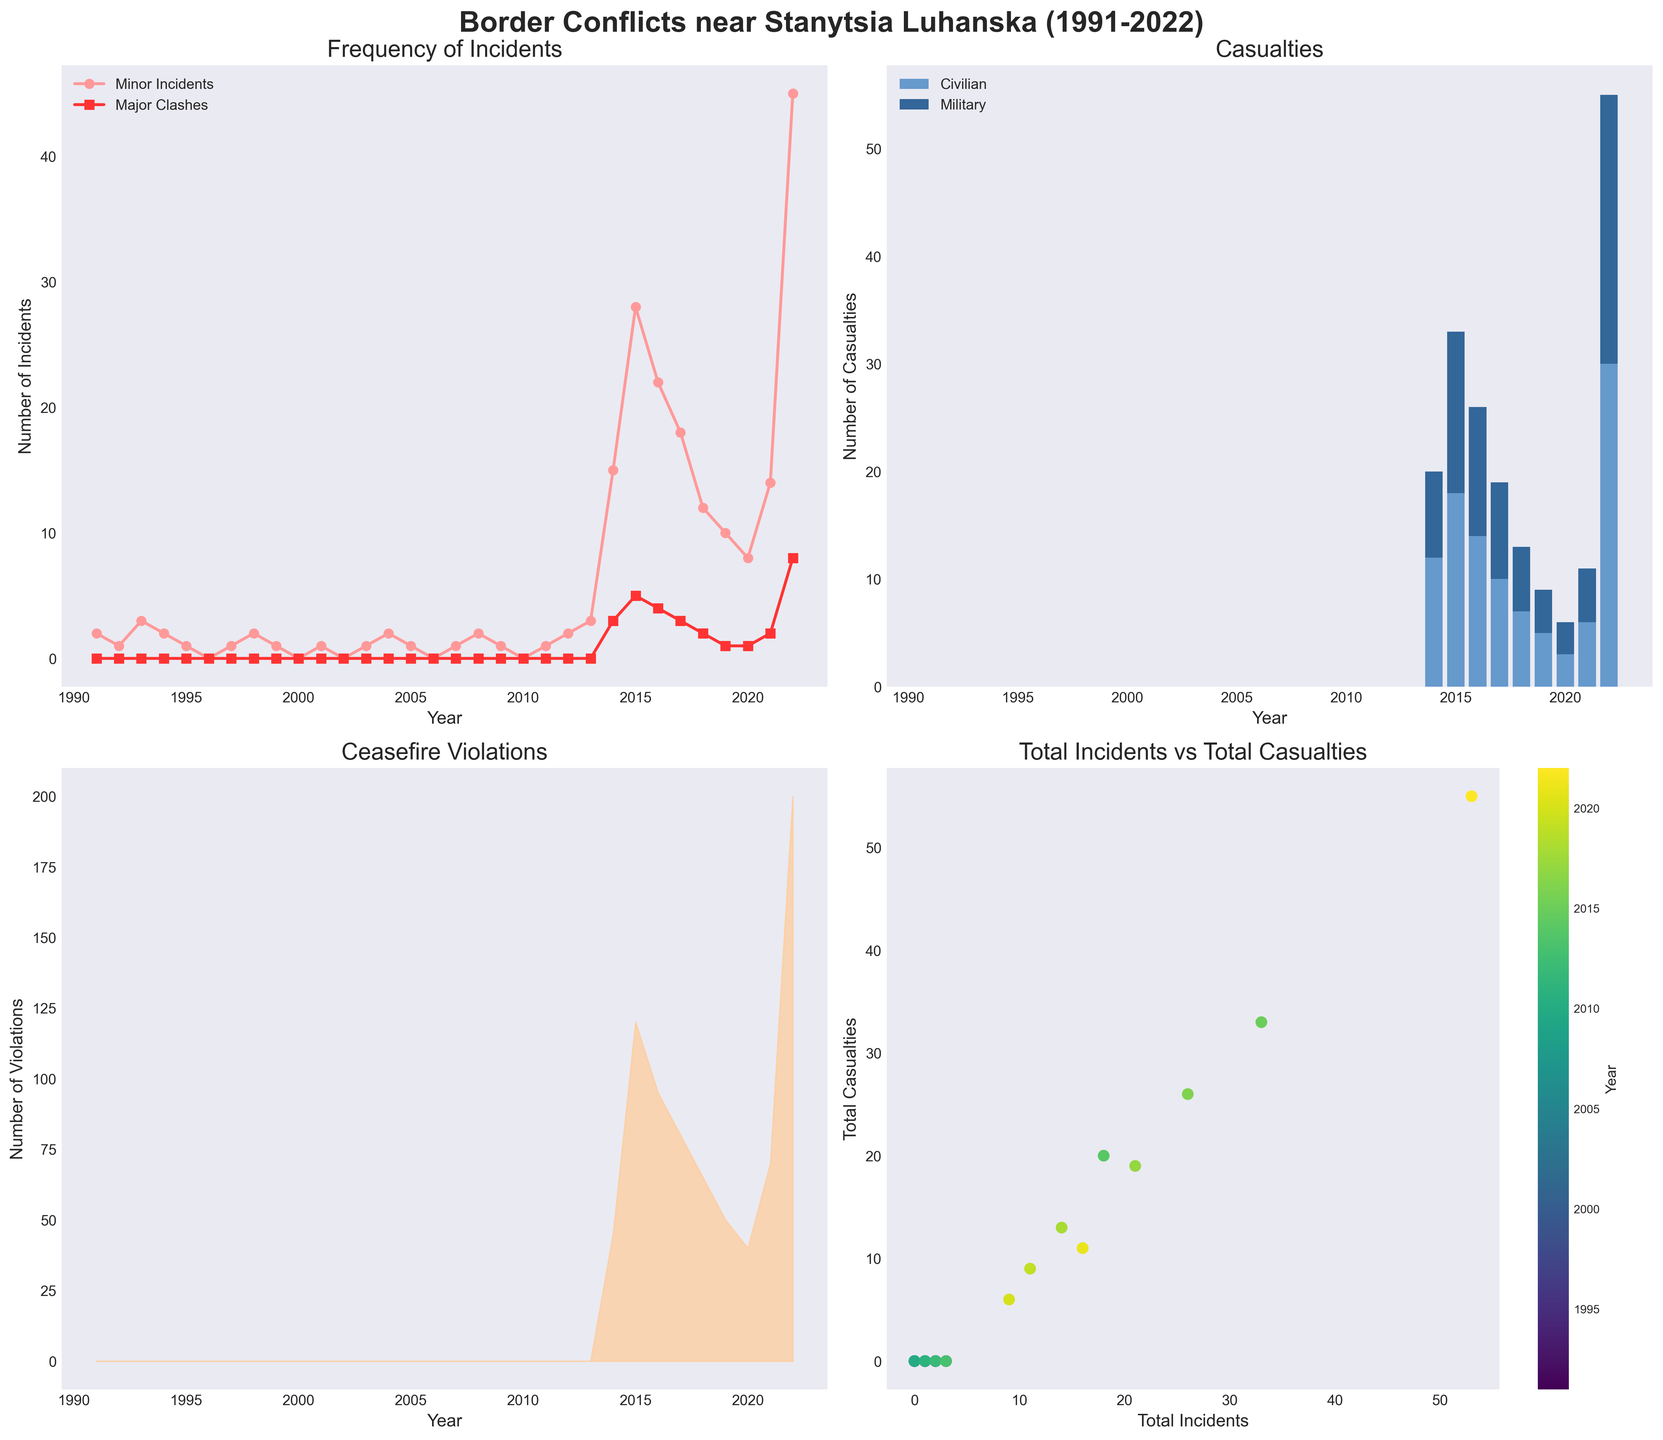What's the total number of Minor Incidents and Major Clashes in 2015? In 2015, according to the plot, Minor Incidents is 28 and Major Clashes is 5. To find the total number, sum them: 28 + 5 = 33
Answer: 33 Which year has the highest number of Ceasefire Violations? From the area plot for Ceasefire Violations, the peak is in 2022 which reaches the highest point on the vertical scale.
Answer: 2022 How does the number of Ceasefire Violations in 2022 compare to 2016? In 2022, the number of Ceasefire Violations is 200, while in 2016, it is 95. Comparing 200 to 95 shows that 2022 has more violations.
Answer: 2022 has more What can be inferred about the trend in Major Clashes from 2014 to 2022? From 2014 onwards, there is an increase in Major Clashes peaking at 8 in 2022, indicating an upward trend in the later years.
Answer: Increasing trend What is the total number of casualties in 2017? From the stacked bar plot, in 2017, Civilian Casualties are 10 and Military Casualties are 9. Summing these gives 10 + 9 = 19.
Answer: 19 In which year did the number of Minor Incidents first exceed 10? In the line plot for Minor Incidents, the first year where the value exceeds 10 is 2014.
Answer: 2014 Compare the number of Minor Incidents between 1991 and 2001. Which year had more? From the line plot, in 1991 there were 2 Minor Incidents, and in 2001 there was 1 Minor Incident. So, 1991 had more.
Answer: 1991 Is there a correlation between Total Incidents and Total Casualties? From the scatter plot with different year colors, as Total Incidents increase, Total Casualties also tend to increase, indicating a positive correlation.
Answer: Positive correlation What is the average number of Major Clashes between 2014 and 2022? The number of Major Clashes each year from 2014 to 2022 is 3, 5, 4, 3, 2, 1,1, 2, 8. Summing these gives 3+5+4+3+2+1+1+2+8 = 29, and the average is 29/9.
Answer: 3.22 By how much did Civilian Casualties increase from 2013 to 2014? In 2013, Civilian Casualties were 0, and in 2014, they were 12. The increase is 12 - 0 = 12.
Answer: 12 